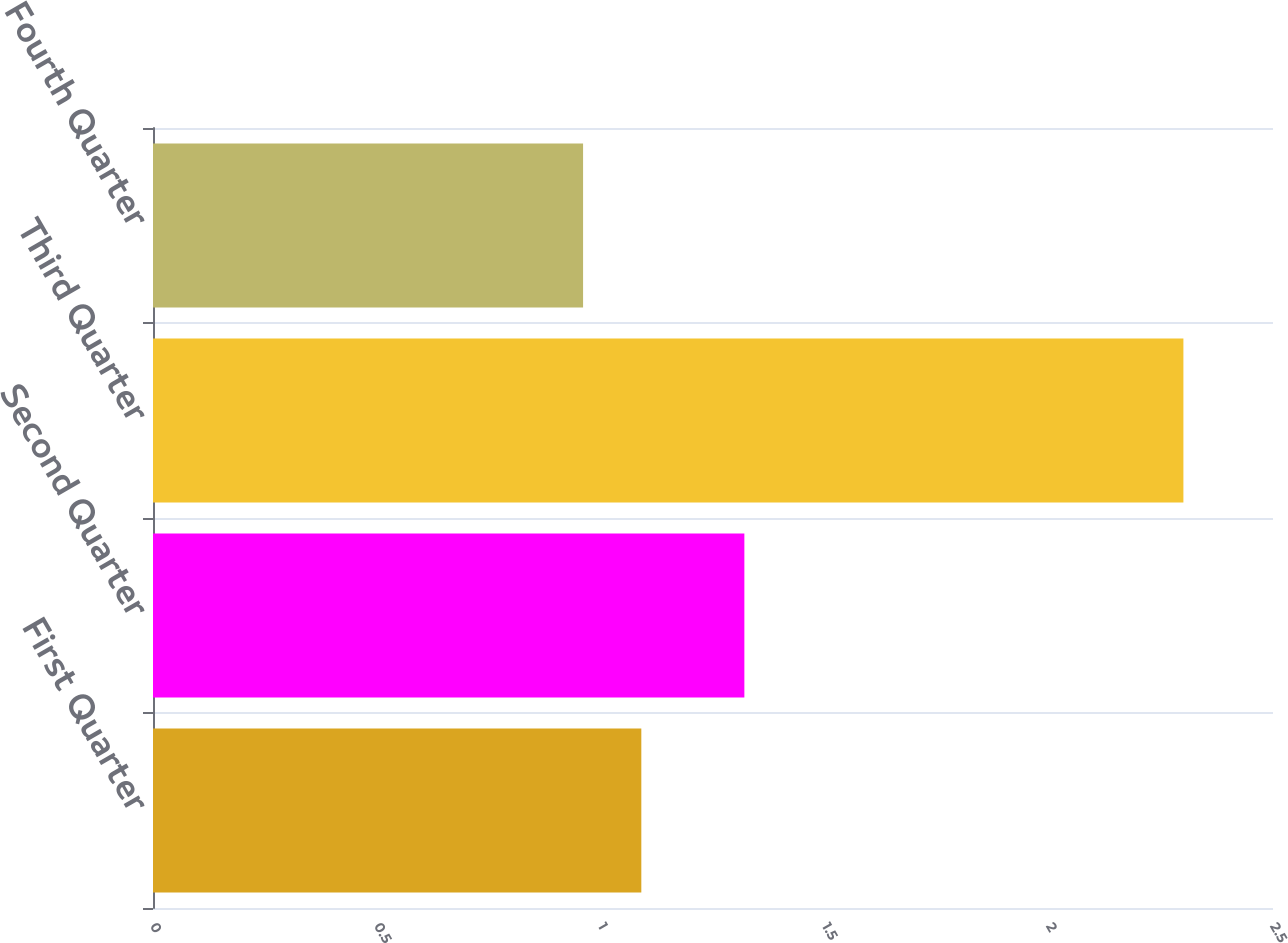<chart> <loc_0><loc_0><loc_500><loc_500><bar_chart><fcel>First Quarter<fcel>Second Quarter<fcel>Third Quarter<fcel>Fourth Quarter<nl><fcel>1.09<fcel>1.32<fcel>2.3<fcel>0.96<nl></chart> 